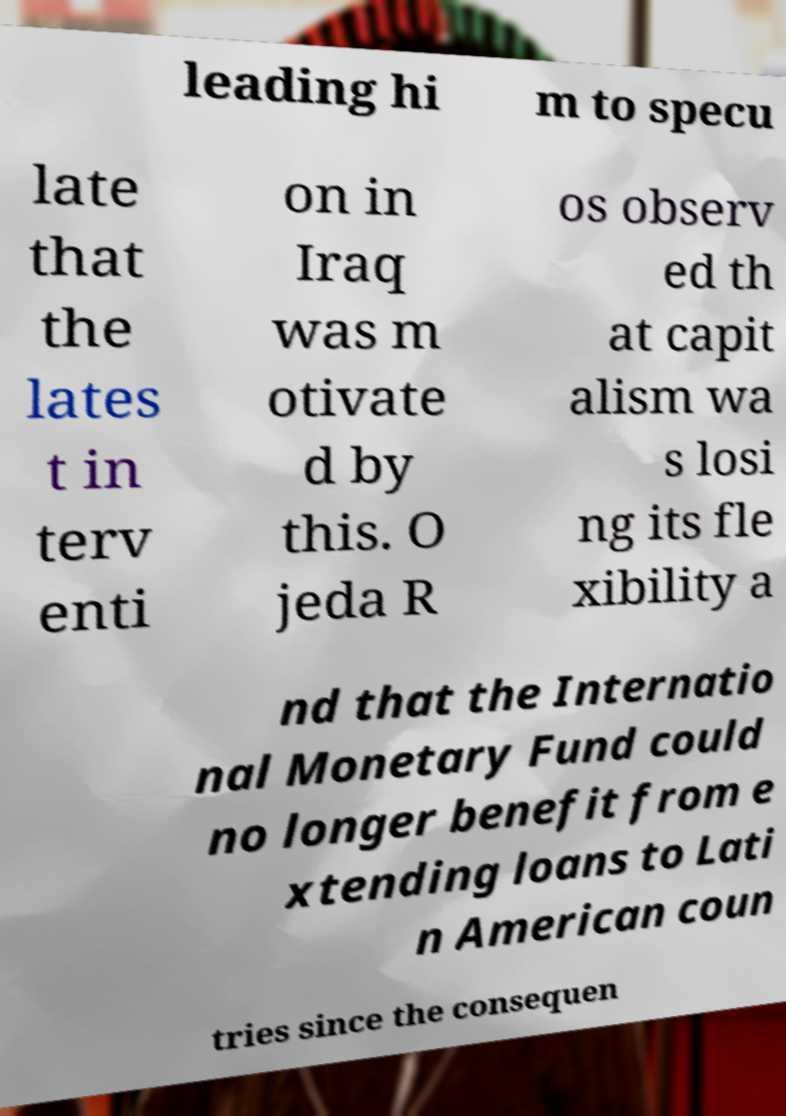Can you read and provide the text displayed in the image?This photo seems to have some interesting text. Can you extract and type it out for me? leading hi m to specu late that the lates t in terv enti on in Iraq was m otivate d by this. O jeda R os observ ed th at capit alism wa s losi ng its fle xibility a nd that the Internatio nal Monetary Fund could no longer benefit from e xtending loans to Lati n American coun tries since the consequen 